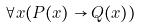Convert formula to latex. <formula><loc_0><loc_0><loc_500><loc_500>\forall x ( P ( x ) \rightarrow Q ( x ) )</formula> 